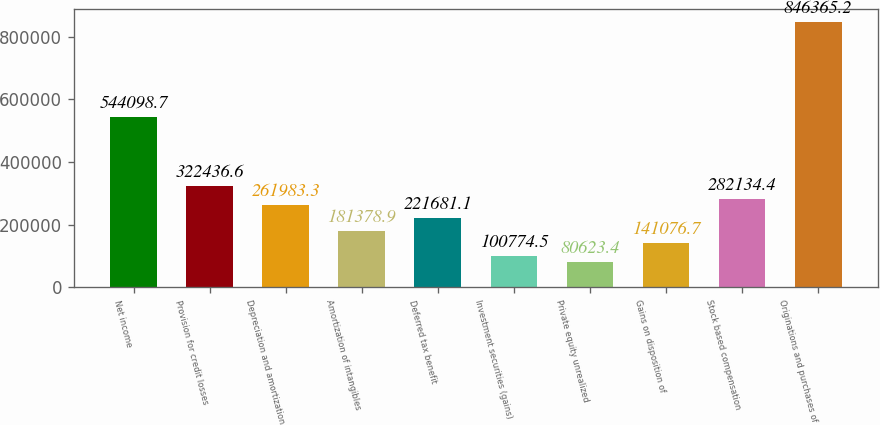Convert chart to OTSL. <chart><loc_0><loc_0><loc_500><loc_500><bar_chart><fcel>Net income<fcel>Provision for credit losses<fcel>Depreciation and amortization<fcel>Amortization of intangibles<fcel>Deferred tax benefit<fcel>Investment securities (gains)<fcel>Private equity unrealized<fcel>Gains on disposition of<fcel>Stock based compensation<fcel>Originations and purchases of<nl><fcel>544099<fcel>322437<fcel>261983<fcel>181379<fcel>221681<fcel>100774<fcel>80623.4<fcel>141077<fcel>282134<fcel>846365<nl></chart> 